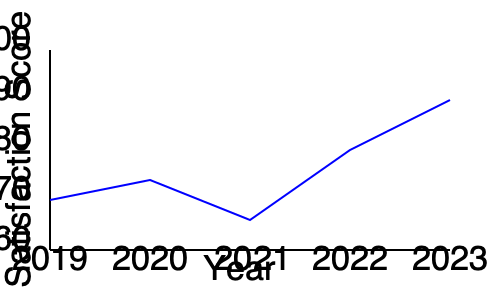Based on the employee satisfaction trends shown in the line graph, which year saw the most significant improvement in employee satisfaction scores, and what factors might you, as a department supervisor, consider investigating to understand and potentially replicate this positive change? To answer this question, let's analyze the graph step-by-step:

1. Examine the trend line:
   - 2019 to 2020: Slight decrease
   - 2020 to 2021: Increase
   - 2021 to 2022: Significant increase
   - 2022 to 2023: Continued increase

2. Identify the most significant improvement:
   The steepest positive slope occurs between 2021 and 2022, indicating the most significant improvement in employee satisfaction scores during this period.

3. Factors to consider investigating:
   a) Changes in company policies or benefits introduced in 2021 or early 2022
   b) Leadership changes or new management strategies implemented during this time
   c) Employee engagement initiatives or programs launched in this period
   d) Improvements in work environment or office facilities
   e) Changes in workload distribution or project management approaches
   f) Enhanced communication strategies between management and employees
   g) Professional development opportunities or training programs introduced
   h) Recognition and reward systems implemented or improved
   i) Adjustments to work-life balance policies

4. As a department supervisor, you should:
   - Collaborate with the HR coordinator to gather data on these factors
   - Conduct surveys or interviews with employees to understand their perspectives
   - Analyze the impact of specific initiatives on employee satisfaction
   - Identify best practices that can be maintained or expanded
   - Develop strategies to sustain the positive trend in employee satisfaction

By investigating these factors, you can gain insights into what drove the improvement and work towards replicating or enhancing these positive changes across your department and the organization.
Answer: 2021 to 2022; investigate policy changes, leadership strategies, engagement initiatives, work environment improvements, and enhanced communication implemented during this period. 